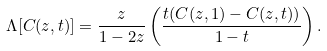Convert formula to latex. <formula><loc_0><loc_0><loc_500><loc_500>\Lambda [ C ( z , t ) ] = \frac { z } { 1 - 2 z } \left ( \frac { t ( C ( z , 1 ) - C ( z , t ) ) } { 1 - t } \right ) .</formula> 